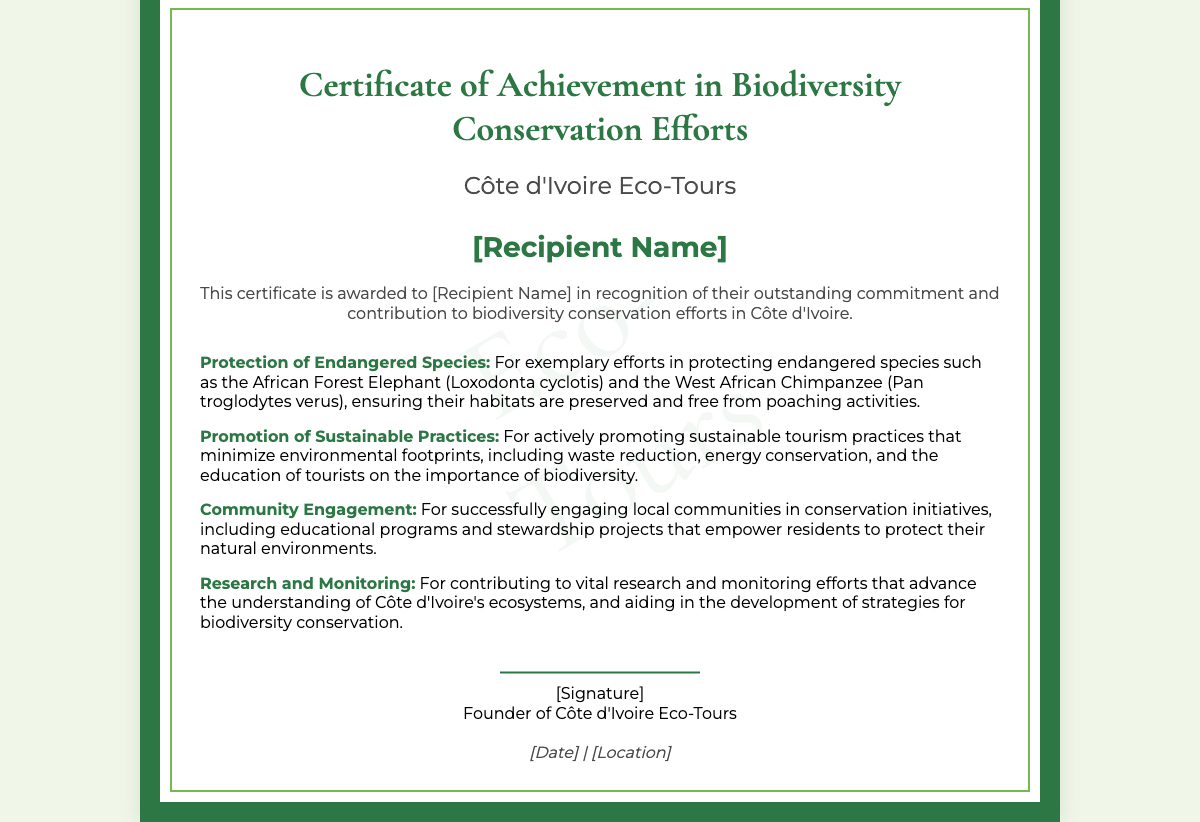What is the title of the certificate? The title of the certificate is prominently displayed at the top of the document.
Answer: Certificate of Achievement in Biodiversity Conservation Efforts Who is the issuing organization? The issuing organization's name is located below the title.
Answer: Côte d'Ivoire Eco-Tours What is the name of the recipient? The name of the recipient is indicated in the designated section of the document.
Answer: [Recipient Name] Which endangered species are mentioned in the achievements? The endangered species referenced are listed in the achievement details.
Answer: African Forest Elephant and West African Chimpanzee What sustainable practices are promoted? The sustainable practices are described within the achievements section of the document.
Answer: Waste reduction, energy conservation What type of community initiatives are mentioned? The community initiatives highlighted involve educational programs and stewardship projects.
Answer: Educational programs and stewardship projects Who signed the certificate? The signature section indicates who signed the certificate.
Answer: [Signature] What visual element is included to enhance the certificate? A visual element that enhances the certificate is described in the document layout.
Answer: Watermark 